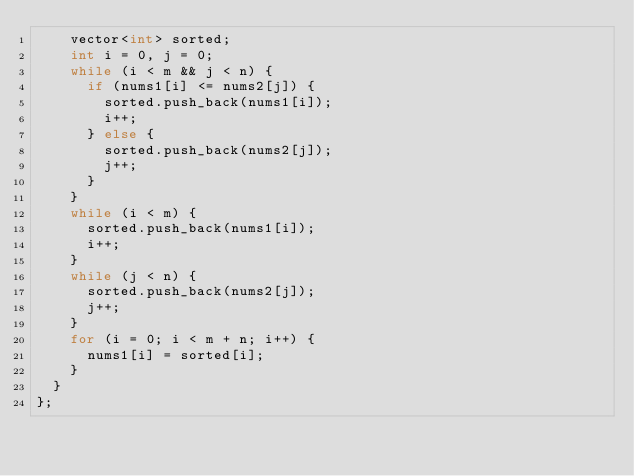<code> <loc_0><loc_0><loc_500><loc_500><_C++_>    vector<int> sorted;
    int i = 0, j = 0;
    while (i < m && j < n) {
      if (nums1[i] <= nums2[j]) {
        sorted.push_back(nums1[i]);
        i++;
      } else {
        sorted.push_back(nums2[j]);
        j++;
      }
    }
    while (i < m) {
      sorted.push_back(nums1[i]);
      i++;
    }
    while (j < n) {
      sorted.push_back(nums2[j]);
      j++;
    }
    for (i = 0; i < m + n; i++) {
      nums1[i] = sorted[i];
    }
  }
};
</code> 